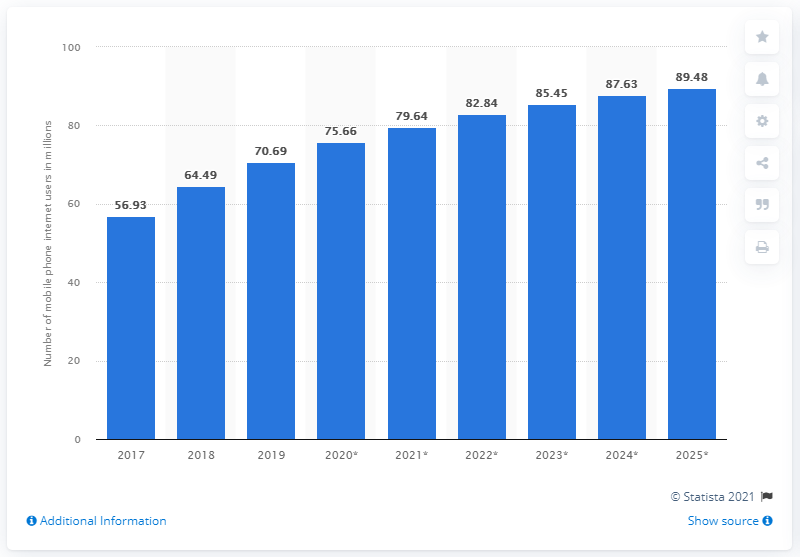Point out several critical features in this image. By 2025, it is projected that approximately 89.48% of the Philippine population will use the internet. In 2019, an estimated 70.69% of the Philippine population accessed the internet through their mobile phones. 